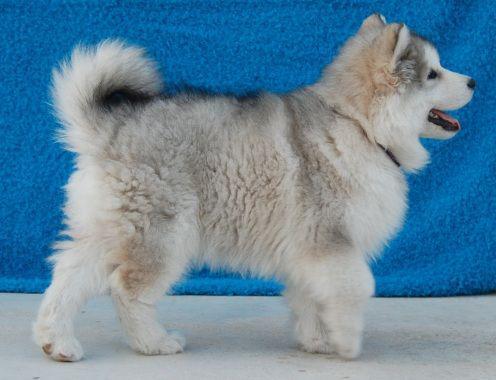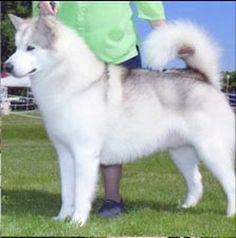The first image is the image on the left, the second image is the image on the right. For the images shown, is this caption "Exactly one dog is sitting." true? Answer yes or no. No. The first image is the image on the left, the second image is the image on the right. For the images shown, is this caption "The left image features a puppy sitting upright in profile, and the right image features a grey-and-white husky facing forward." true? Answer yes or no. No. 